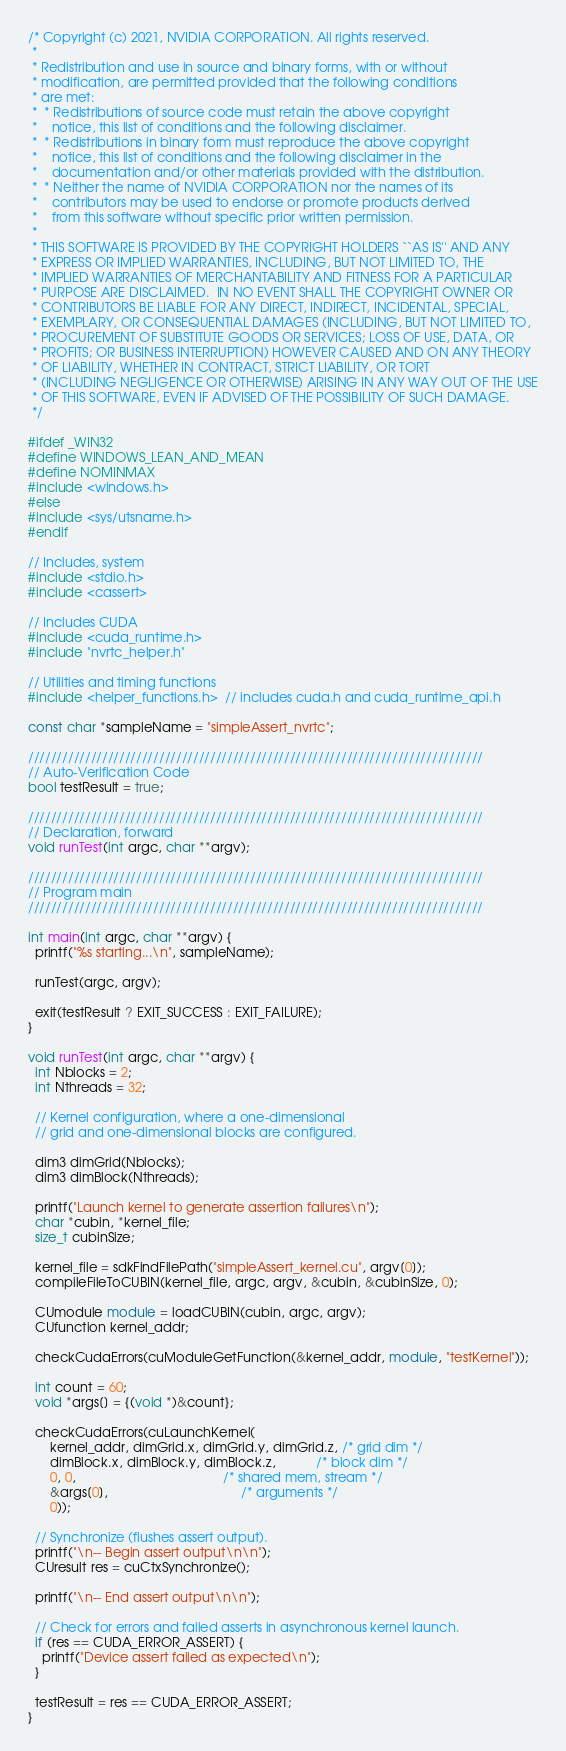Convert code to text. <code><loc_0><loc_0><loc_500><loc_500><_C++_>/* Copyright (c) 2021, NVIDIA CORPORATION. All rights reserved.
 *
 * Redistribution and use in source and binary forms, with or without
 * modification, are permitted provided that the following conditions
 * are met:
 *  * Redistributions of source code must retain the above copyright
 *    notice, this list of conditions and the following disclaimer.
 *  * Redistributions in binary form must reproduce the above copyright
 *    notice, this list of conditions and the following disclaimer in the
 *    documentation and/or other materials provided with the distribution.
 *  * Neither the name of NVIDIA CORPORATION nor the names of its
 *    contributors may be used to endorse or promote products derived
 *    from this software without specific prior written permission.
 *
 * THIS SOFTWARE IS PROVIDED BY THE COPYRIGHT HOLDERS ``AS IS'' AND ANY
 * EXPRESS OR IMPLIED WARRANTIES, INCLUDING, BUT NOT LIMITED TO, THE
 * IMPLIED WARRANTIES OF MERCHANTABILITY AND FITNESS FOR A PARTICULAR
 * PURPOSE ARE DISCLAIMED.  IN NO EVENT SHALL THE COPYRIGHT OWNER OR
 * CONTRIBUTORS BE LIABLE FOR ANY DIRECT, INDIRECT, INCIDENTAL, SPECIAL,
 * EXEMPLARY, OR CONSEQUENTIAL DAMAGES (INCLUDING, BUT NOT LIMITED TO,
 * PROCUREMENT OF SUBSTITUTE GOODS OR SERVICES; LOSS OF USE, DATA, OR
 * PROFITS; OR BUSINESS INTERRUPTION) HOWEVER CAUSED AND ON ANY THEORY
 * OF LIABILITY, WHETHER IN CONTRACT, STRICT LIABILITY, OR TORT
 * (INCLUDING NEGLIGENCE OR OTHERWISE) ARISING IN ANY WAY OUT OF THE USE
 * OF THIS SOFTWARE, EVEN IF ADVISED OF THE POSSIBILITY OF SUCH DAMAGE.
 */

#ifdef _WIN32
#define WINDOWS_LEAN_AND_MEAN
#define NOMINMAX
#include <windows.h>
#else
#include <sys/utsname.h>
#endif

// Includes, system
#include <stdio.h>
#include <cassert>

// Includes CUDA
#include <cuda_runtime.h>
#include "nvrtc_helper.h"

// Utilities and timing functions
#include <helper_functions.h>  // includes cuda.h and cuda_runtime_api.h

const char *sampleName = "simpleAssert_nvrtc";

////////////////////////////////////////////////////////////////////////////////
// Auto-Verification Code
bool testResult = true;

////////////////////////////////////////////////////////////////////////////////
// Declaration, forward
void runTest(int argc, char **argv);

////////////////////////////////////////////////////////////////////////////////
// Program main
////////////////////////////////////////////////////////////////////////////////

int main(int argc, char **argv) {
  printf("%s starting...\n", sampleName);

  runTest(argc, argv);

  exit(testResult ? EXIT_SUCCESS : EXIT_FAILURE);
}

void runTest(int argc, char **argv) {
  int Nblocks = 2;
  int Nthreads = 32;

  // Kernel configuration, where a one-dimensional
  // grid and one-dimensional blocks are configured.

  dim3 dimGrid(Nblocks);
  dim3 dimBlock(Nthreads);

  printf("Launch kernel to generate assertion failures\n");
  char *cubin, *kernel_file;
  size_t cubinSize;

  kernel_file = sdkFindFilePath("simpleAssert_kernel.cu", argv[0]);
  compileFileToCUBIN(kernel_file, argc, argv, &cubin, &cubinSize, 0);

  CUmodule module = loadCUBIN(cubin, argc, argv);
  CUfunction kernel_addr;

  checkCudaErrors(cuModuleGetFunction(&kernel_addr, module, "testKernel"));

  int count = 60;
  void *args[] = {(void *)&count};

  checkCudaErrors(cuLaunchKernel(
      kernel_addr, dimGrid.x, dimGrid.y, dimGrid.z, /* grid dim */
      dimBlock.x, dimBlock.y, dimBlock.z,           /* block dim */
      0, 0,                                         /* shared mem, stream */
      &args[0],                                     /* arguments */
      0));

  // Synchronize (flushes assert output).
  printf("\n-- Begin assert output\n\n");
  CUresult res = cuCtxSynchronize();

  printf("\n-- End assert output\n\n");

  // Check for errors and failed asserts in asynchronous kernel launch.
  if (res == CUDA_ERROR_ASSERT) {
    printf("Device assert failed as expected\n");
  }

  testResult = res == CUDA_ERROR_ASSERT;
}
</code> 